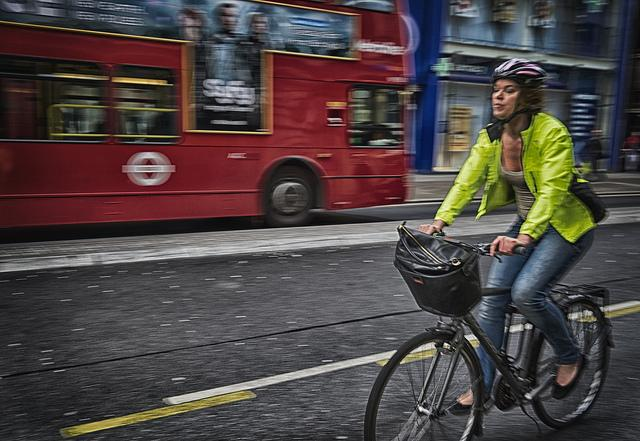What allows the woman on the bike to carry needed items safely? Please explain your reasoning. basket. On the front of the bike there is a basket and it has her items in it. 